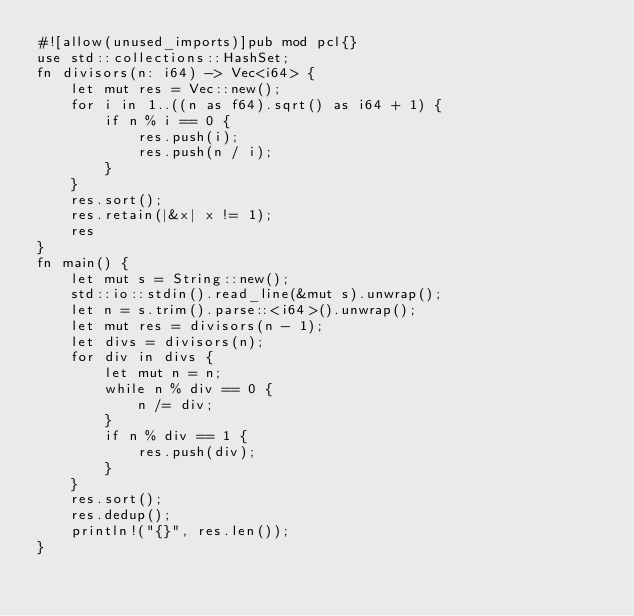<code> <loc_0><loc_0><loc_500><loc_500><_Rust_>#![allow(unused_imports)]pub mod pcl{}
use std::collections::HashSet;
fn divisors(n: i64) -> Vec<i64> {
    let mut res = Vec::new();
    for i in 1..((n as f64).sqrt() as i64 + 1) {
        if n % i == 0 {
            res.push(i);
            res.push(n / i);
        }
    }
    res.sort();
    res.retain(|&x| x != 1);
    res
}
fn main() {
    let mut s = String::new();
    std::io::stdin().read_line(&mut s).unwrap();
    let n = s.trim().parse::<i64>().unwrap();
    let mut res = divisors(n - 1);
    let divs = divisors(n);
    for div in divs {
        let mut n = n;
        while n % div == 0 {
            n /= div;
        }
        if n % div == 1 {
            res.push(div);
        }
    }
    res.sort();
    res.dedup();
    println!("{}", res.len());
}

</code> 